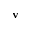Convert formula to latex. <formula><loc_0><loc_0><loc_500><loc_500>v</formula> 